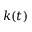Convert formula to latex. <formula><loc_0><loc_0><loc_500><loc_500>k ( t )</formula> 